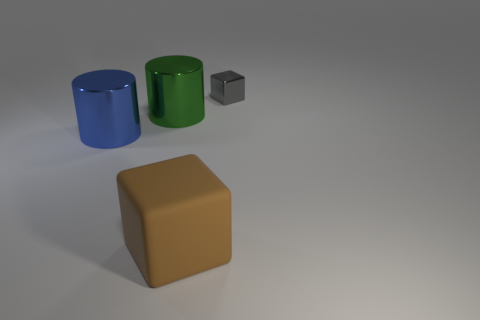What number of things are either blue shiny things that are on the left side of the brown block or big cylinders that are behind the big blue cylinder?
Provide a succinct answer. 2. There is a blue metal thing that is the same size as the brown rubber object; what is its shape?
Give a very brief answer. Cylinder. Are there any other large brown objects that have the same shape as the large brown object?
Provide a short and direct response. No. Are there fewer blue things than objects?
Give a very brief answer. Yes. There is a metallic thing that is on the right side of the large cube; is it the same size as the block that is left of the metallic cube?
Ensure brevity in your answer.  No. What number of things are large yellow metallic balls or large rubber cubes?
Your response must be concise. 1. There is a cube that is in front of the gray shiny thing; what is its size?
Keep it short and to the point. Large. There is a block that is behind the block in front of the small thing; what number of tiny gray things are in front of it?
Keep it short and to the point. 0. Is the small object the same color as the matte thing?
Offer a terse response. No. How many things are in front of the big blue cylinder and behind the green thing?
Make the answer very short. 0. 